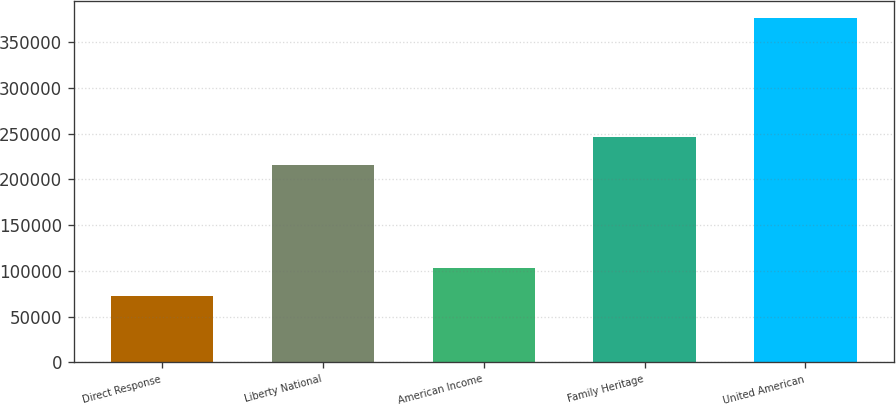Convert chart to OTSL. <chart><loc_0><loc_0><loc_500><loc_500><bar_chart><fcel>Direct Response<fcel>Liberty National<fcel>American Income<fcel>Family Heritage<fcel>United American<nl><fcel>72423<fcel>216139<fcel>102811<fcel>246527<fcel>376302<nl></chart> 